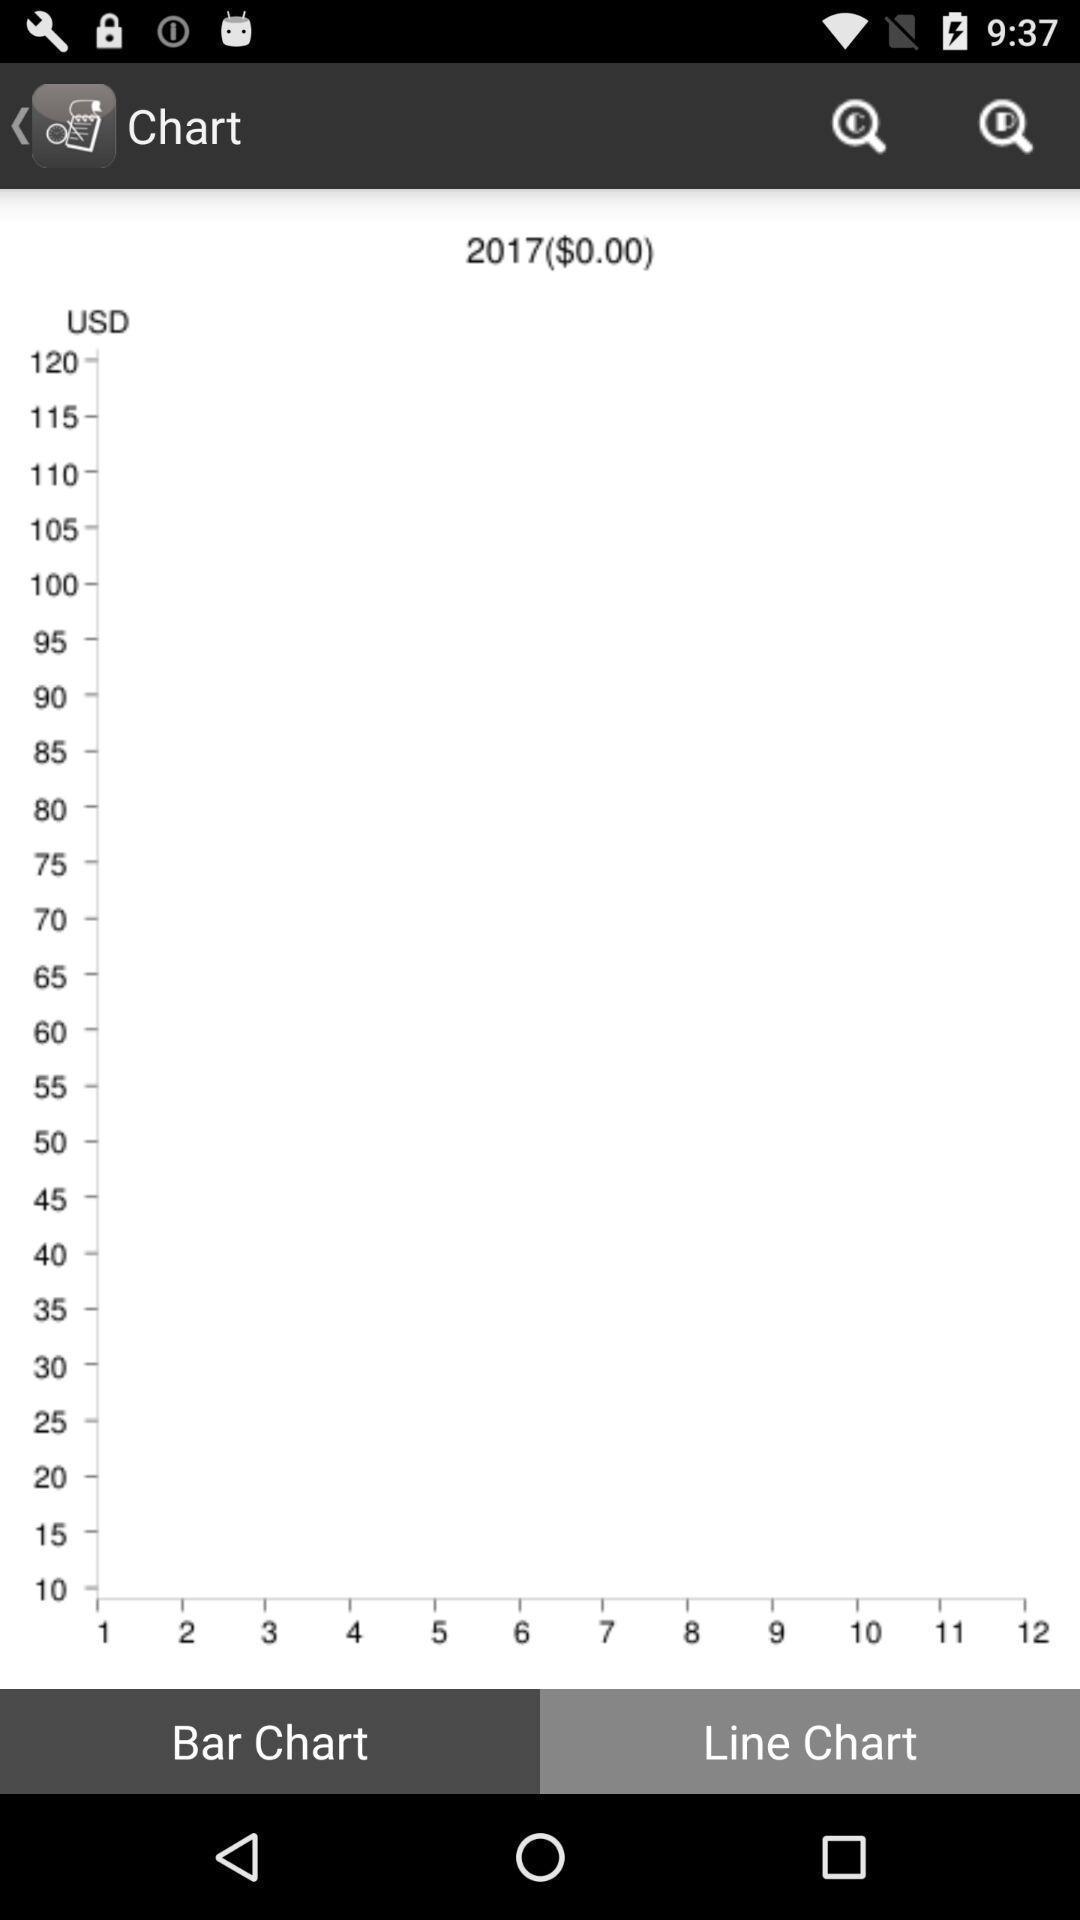Describe this image in words. Page displaying line chart in app. 